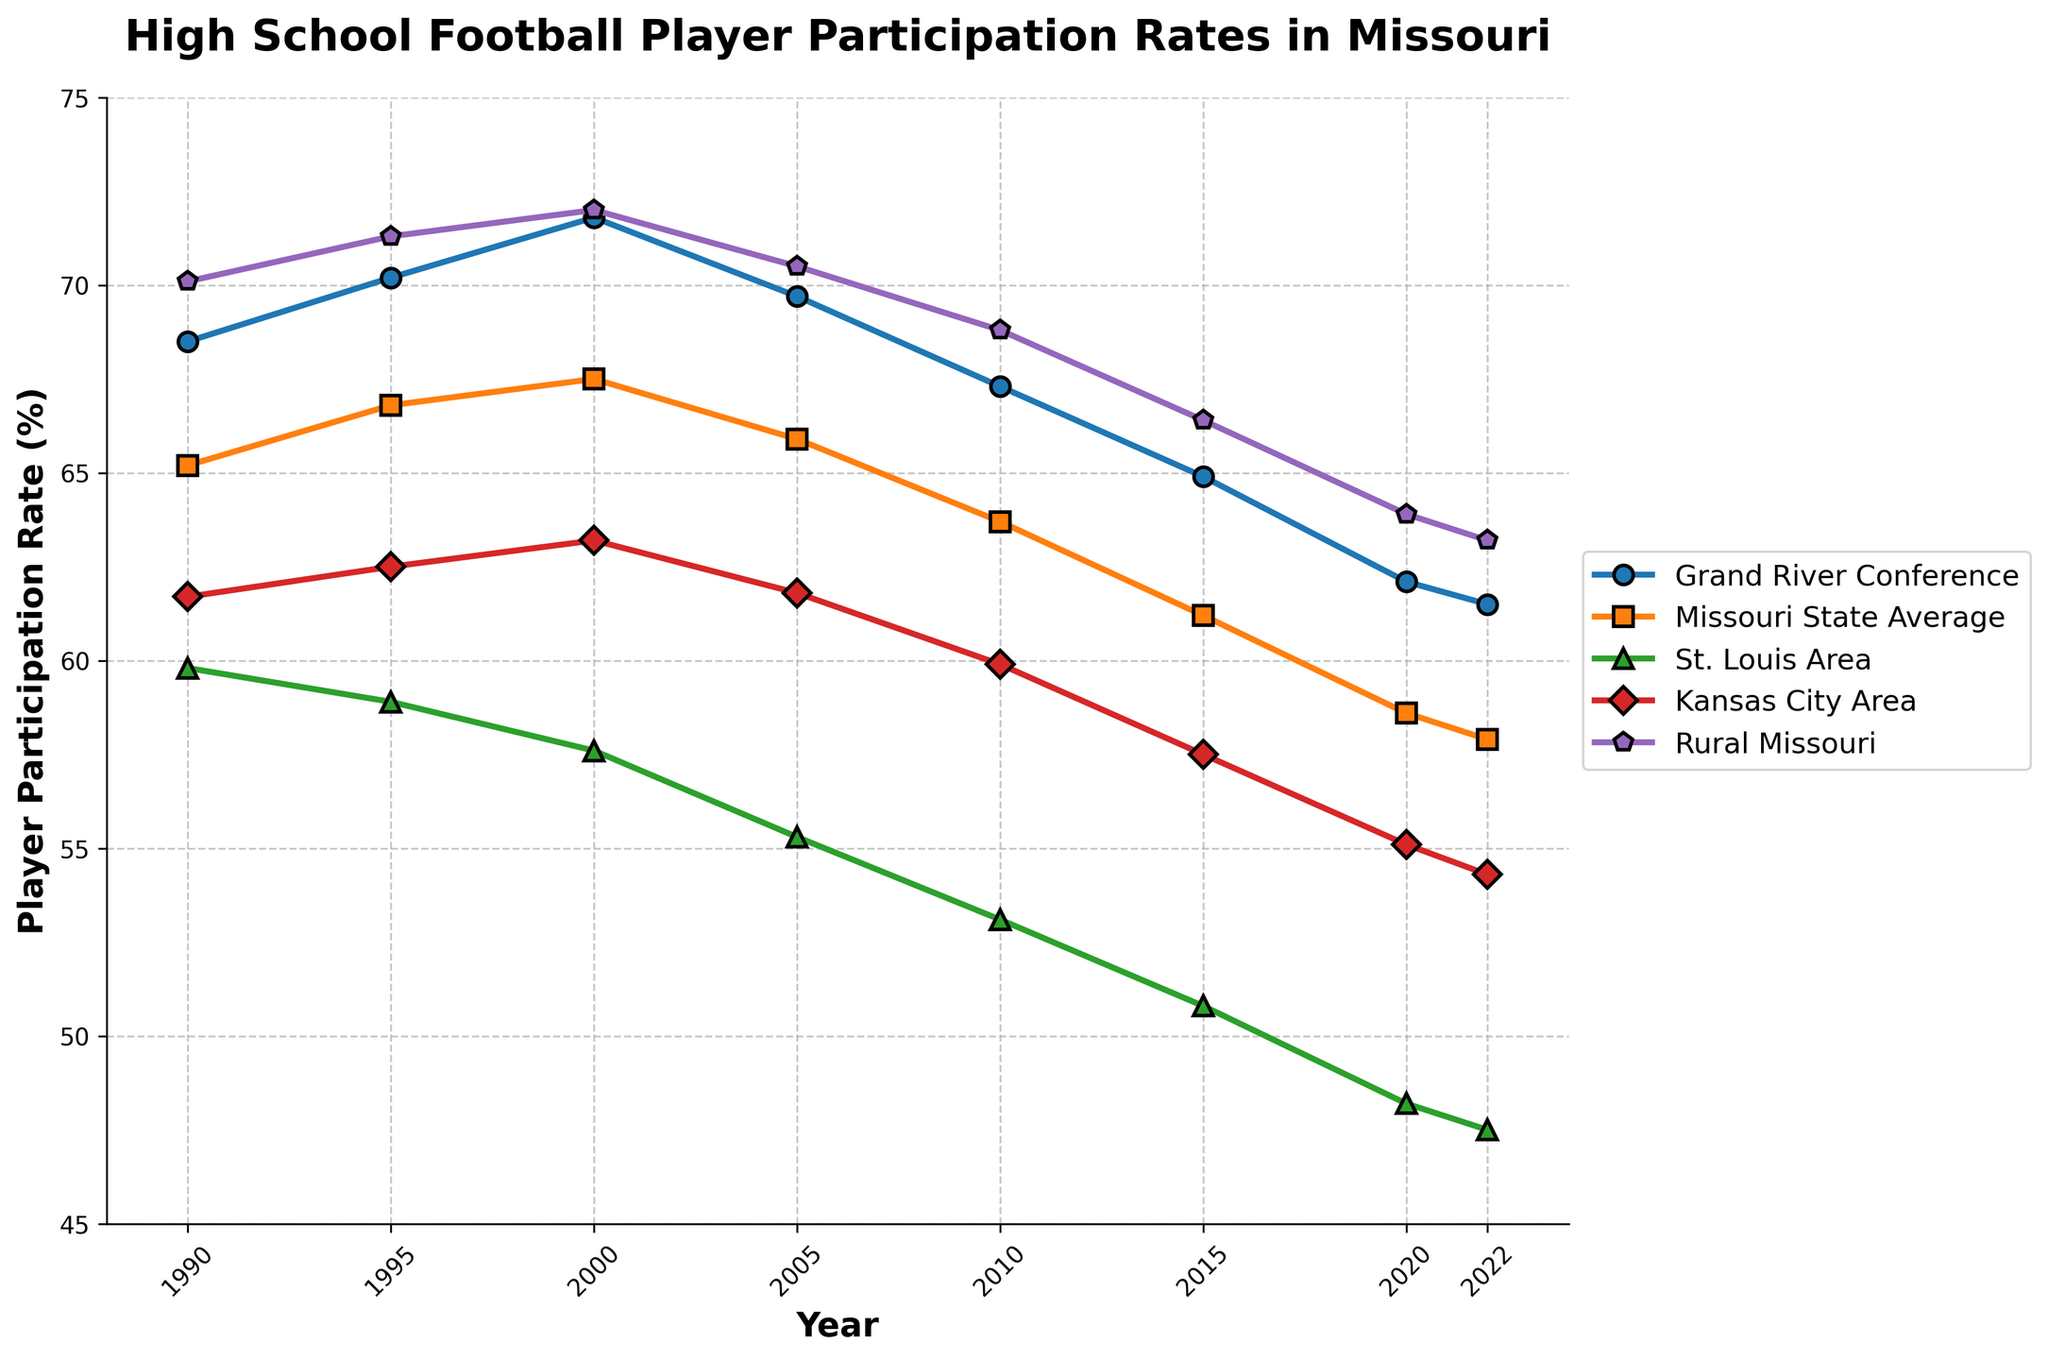What is the trend in player participation rates for the Grand River Conference from 1990 to 2022? The trend can be observed by looking at the plotted line for the Grand River Conference (blue line). From 1990 to 2022, the participation rate shows a declining trend, starting from 68.5% in 1990 and decreasing to 61.5% in 2022.
Answer: Declining Which area had the highest player participation rate in 2000? By observing the plot at the point for the year 2000, we can see that Rural Missouri (purple line) had the highest participation rate at 72.0%.
Answer: Rural Missouri How did the participation rates of Kansas City Area and St. Louis Area compare in 2010? In 2010, the plotted line shows that Kansas City Area (red line) had a participation rate of 59.9%, while St. Louis Area (green line) had a participation rate of 53.1%. Comparing these values, Kansas City Area had a higher rate.
Answer: Kansas City Area had a higher rate What is the average participation rate for Missouri State Average from 1990 to 2022? To find the average, add the values for Missouri State Average across all years and divide by the number of data points. (65.2 + 66.8 + 67.5 + 65.9 + 63.7 + 61.2 + 58.6 + 57.9)/8 = 506.8/8 = 63.35.
Answer: 63.35% Which region experienced the most significant decrease in participation rate from 1990 to 2022? By comparing the year 1990 and 2022 for all regions: 
- Grand River Conference: 68.5% to 61.5% (decrease of 7%)
- Missouri State Average: 65.2% to 57.9% (decrease of 7.3%)
- St. Louis Area: 59.8% to 47.5% (decrease of 12.3%)
- Kansas City Area: 61.7% to 54.3% (decrease of 7.4%)
- Rural Missouri: 70.1% to 63.2% (decrease of 6.9%)
Thus, St. Louis Area experienced the most significant decrease.
Answer: St. Louis Area Which two regions' participation rates were most similar in 2020? For 2020, observe the plotted lines' values: 
- Grand River Conference: 62.1%
- Missouri State Average: 58.6%
- St. Louis Area: 48.2%
- Kansas City Area: 55.1%
- Rural Missouri: 63.9%
The Grand River Conference and Rural Missouri had the closest values at 62.1% and 63.9%.
Answer: Grand River Conference and Rural Missouri Between 2005 and 2015, which region showed the largest drop in participation rate? Calculate the difference between 2005 and 2015 rates for each region:
- Grand River Conference: 69.7% to 64.9% (drop of 4.8%)
- Missouri State Average: 65.9% to 61.2% (drop of 4.7%)
- St. Louis Area: 55.3% to 50.8% (drop of 4.5%)
- Kansas City Area: 61.8% to 57.5% (drop of 4.3%)
- Rural Missouri: 70.5% to 66.4% (drop of 4.1%)
The Grand River Conference showed the largest drop of 4.8%.
Answer: Grand River Conference What is the difference in participation rates between Grand River Conference and St. Louis Area in 2022? In 2022, the Grand River Conference had a participation rate of 61.5% and St. Louis Area had 47.5%. The difference between them is 61.5% - 47.5%, which equals 14%.
Answer: 14% How did Rural Missouri's participation rate change from 1990 to 1995? Observe the plot for Rural Missouri (purple line) for the years 1990 and 1995. In 1990, it was 70.1% and in 1995, it increased to 71.3%. The change is 71.3% - 70.1% = 1.2%.
Answer: Increased by 1.2% 